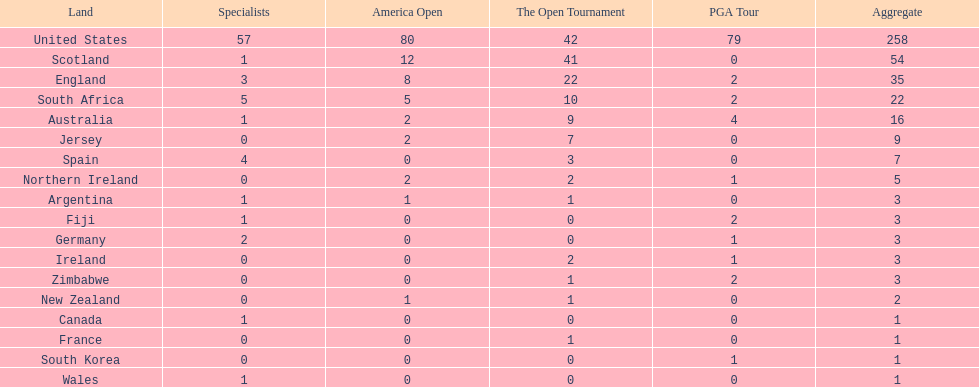How many countries have produced the same number of championship golfers as canada? 3. 